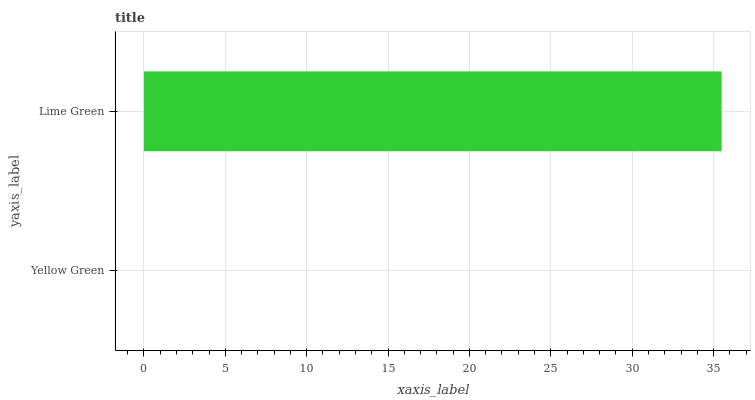Is Yellow Green the minimum?
Answer yes or no. Yes. Is Lime Green the maximum?
Answer yes or no. Yes. Is Lime Green the minimum?
Answer yes or no. No. Is Lime Green greater than Yellow Green?
Answer yes or no. Yes. Is Yellow Green less than Lime Green?
Answer yes or no. Yes. Is Yellow Green greater than Lime Green?
Answer yes or no. No. Is Lime Green less than Yellow Green?
Answer yes or no. No. Is Lime Green the high median?
Answer yes or no. Yes. Is Yellow Green the low median?
Answer yes or no. Yes. Is Yellow Green the high median?
Answer yes or no. No. Is Lime Green the low median?
Answer yes or no. No. 